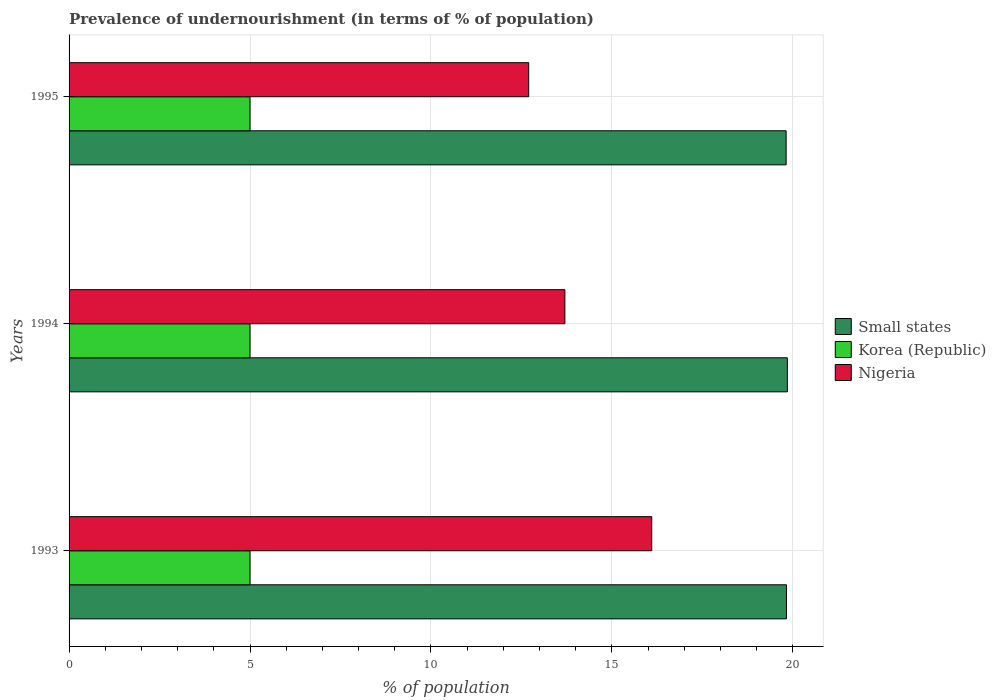How many different coloured bars are there?
Provide a short and direct response. 3. How many groups of bars are there?
Offer a terse response. 3. Are the number of bars per tick equal to the number of legend labels?
Your answer should be compact. Yes. Are the number of bars on each tick of the Y-axis equal?
Offer a terse response. Yes. How many bars are there on the 2nd tick from the top?
Keep it short and to the point. 3. In how many cases, is the number of bars for a given year not equal to the number of legend labels?
Give a very brief answer. 0. What is the percentage of undernourished population in Small states in 1995?
Keep it short and to the point. 19.81. Across all years, what is the maximum percentage of undernourished population in Korea (Republic)?
Provide a short and direct response. 5. Across all years, what is the minimum percentage of undernourished population in Small states?
Offer a terse response. 19.81. In which year was the percentage of undernourished population in Nigeria maximum?
Provide a succinct answer. 1993. What is the total percentage of undernourished population in Small states in the graph?
Offer a terse response. 59.48. What is the difference between the percentage of undernourished population in Small states in 1993 and that in 1995?
Offer a very short reply. 0.01. What is the difference between the percentage of undernourished population in Korea (Republic) in 1994 and the percentage of undernourished population in Small states in 1995?
Your answer should be compact. -14.81. What is the average percentage of undernourished population in Korea (Republic) per year?
Your answer should be compact. 5. In the year 1994, what is the difference between the percentage of undernourished population in Nigeria and percentage of undernourished population in Small states?
Keep it short and to the point. -6.15. In how many years, is the percentage of undernourished population in Nigeria greater than 6 %?
Your response must be concise. 3. What is the ratio of the percentage of undernourished population in Nigeria in 1993 to that in 1994?
Provide a short and direct response. 1.18. Is the percentage of undernourished population in Korea (Republic) in 1993 less than that in 1994?
Your answer should be compact. No. What is the difference between the highest and the second highest percentage of undernourished population in Korea (Republic)?
Give a very brief answer. 0. What is the difference between the highest and the lowest percentage of undernourished population in Small states?
Keep it short and to the point. 0.03. In how many years, is the percentage of undernourished population in Korea (Republic) greater than the average percentage of undernourished population in Korea (Republic) taken over all years?
Keep it short and to the point. 0. What does the 1st bar from the top in 1993 represents?
Ensure brevity in your answer.  Nigeria. What does the 2nd bar from the bottom in 1993 represents?
Keep it short and to the point. Korea (Republic). Is it the case that in every year, the sum of the percentage of undernourished population in Korea (Republic) and percentage of undernourished population in Small states is greater than the percentage of undernourished population in Nigeria?
Ensure brevity in your answer.  Yes. Are all the bars in the graph horizontal?
Ensure brevity in your answer.  Yes. What is the difference between two consecutive major ticks on the X-axis?
Ensure brevity in your answer.  5. Are the values on the major ticks of X-axis written in scientific E-notation?
Provide a short and direct response. No. What is the title of the graph?
Your response must be concise. Prevalence of undernourishment (in terms of % of population). Does "Trinidad and Tobago" appear as one of the legend labels in the graph?
Your response must be concise. No. What is the label or title of the X-axis?
Your answer should be compact. % of population. What is the label or title of the Y-axis?
Offer a very short reply. Years. What is the % of population in Small states in 1993?
Give a very brief answer. 19.82. What is the % of population of Korea (Republic) in 1993?
Make the answer very short. 5. What is the % of population in Nigeria in 1993?
Give a very brief answer. 16.1. What is the % of population in Small states in 1994?
Your response must be concise. 19.85. What is the % of population in Nigeria in 1994?
Keep it short and to the point. 13.7. What is the % of population in Small states in 1995?
Your answer should be compact. 19.81. Across all years, what is the maximum % of population in Small states?
Offer a very short reply. 19.85. Across all years, what is the maximum % of population of Korea (Republic)?
Ensure brevity in your answer.  5. Across all years, what is the maximum % of population in Nigeria?
Ensure brevity in your answer.  16.1. Across all years, what is the minimum % of population in Small states?
Your answer should be compact. 19.81. Across all years, what is the minimum % of population in Korea (Republic)?
Ensure brevity in your answer.  5. What is the total % of population in Small states in the graph?
Ensure brevity in your answer.  59.48. What is the total % of population in Nigeria in the graph?
Provide a succinct answer. 42.5. What is the difference between the % of population in Small states in 1993 and that in 1994?
Offer a very short reply. -0.02. What is the difference between the % of population in Korea (Republic) in 1993 and that in 1994?
Ensure brevity in your answer.  0. What is the difference between the % of population in Small states in 1993 and that in 1995?
Your answer should be compact. 0.01. What is the difference between the % of population of Korea (Republic) in 1993 and that in 1995?
Your response must be concise. 0. What is the difference between the % of population of Nigeria in 1993 and that in 1995?
Offer a very short reply. 3.4. What is the difference between the % of population of Small states in 1994 and that in 1995?
Make the answer very short. 0.03. What is the difference between the % of population of Korea (Republic) in 1994 and that in 1995?
Your answer should be very brief. 0. What is the difference between the % of population in Small states in 1993 and the % of population in Korea (Republic) in 1994?
Your answer should be very brief. 14.82. What is the difference between the % of population in Small states in 1993 and the % of population in Nigeria in 1994?
Offer a terse response. 6.12. What is the difference between the % of population of Korea (Republic) in 1993 and the % of population of Nigeria in 1994?
Your answer should be very brief. -8.7. What is the difference between the % of population of Small states in 1993 and the % of population of Korea (Republic) in 1995?
Keep it short and to the point. 14.82. What is the difference between the % of population in Small states in 1993 and the % of population in Nigeria in 1995?
Offer a very short reply. 7.12. What is the difference between the % of population of Small states in 1994 and the % of population of Korea (Republic) in 1995?
Keep it short and to the point. 14.85. What is the difference between the % of population in Small states in 1994 and the % of population in Nigeria in 1995?
Ensure brevity in your answer.  7.15. What is the difference between the % of population of Korea (Republic) in 1994 and the % of population of Nigeria in 1995?
Keep it short and to the point. -7.7. What is the average % of population of Small states per year?
Provide a succinct answer. 19.83. What is the average % of population of Nigeria per year?
Give a very brief answer. 14.17. In the year 1993, what is the difference between the % of population in Small states and % of population in Korea (Republic)?
Your answer should be compact. 14.82. In the year 1993, what is the difference between the % of population of Small states and % of population of Nigeria?
Keep it short and to the point. 3.72. In the year 1994, what is the difference between the % of population in Small states and % of population in Korea (Republic)?
Make the answer very short. 14.85. In the year 1994, what is the difference between the % of population of Small states and % of population of Nigeria?
Ensure brevity in your answer.  6.15. In the year 1995, what is the difference between the % of population in Small states and % of population in Korea (Republic)?
Give a very brief answer. 14.81. In the year 1995, what is the difference between the % of population in Small states and % of population in Nigeria?
Keep it short and to the point. 7.11. In the year 1995, what is the difference between the % of population of Korea (Republic) and % of population of Nigeria?
Your response must be concise. -7.7. What is the ratio of the % of population in Small states in 1993 to that in 1994?
Your answer should be compact. 1. What is the ratio of the % of population in Nigeria in 1993 to that in 1994?
Provide a short and direct response. 1.18. What is the ratio of the % of population in Small states in 1993 to that in 1995?
Provide a short and direct response. 1. What is the ratio of the % of population of Nigeria in 1993 to that in 1995?
Provide a short and direct response. 1.27. What is the ratio of the % of population of Korea (Republic) in 1994 to that in 1995?
Ensure brevity in your answer.  1. What is the ratio of the % of population of Nigeria in 1994 to that in 1995?
Provide a short and direct response. 1.08. What is the difference between the highest and the second highest % of population in Small states?
Keep it short and to the point. 0.02. What is the difference between the highest and the lowest % of population in Small states?
Your answer should be very brief. 0.03. What is the difference between the highest and the lowest % of population in Korea (Republic)?
Give a very brief answer. 0. What is the difference between the highest and the lowest % of population in Nigeria?
Provide a short and direct response. 3.4. 